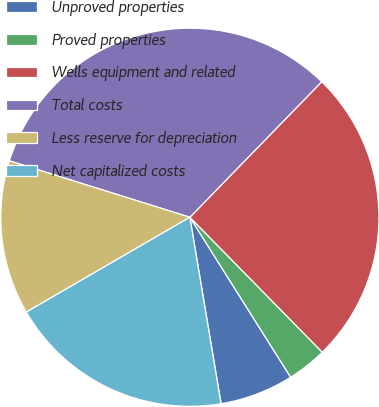Convert chart. <chart><loc_0><loc_0><loc_500><loc_500><pie_chart><fcel>Unproved properties<fcel>Proved properties<fcel>Wells equipment and related<fcel>Total costs<fcel>Less reserve for depreciation<fcel>Net capitalized costs<nl><fcel>6.31%<fcel>3.4%<fcel>25.37%<fcel>32.46%<fcel>13.19%<fcel>19.27%<nl></chart> 